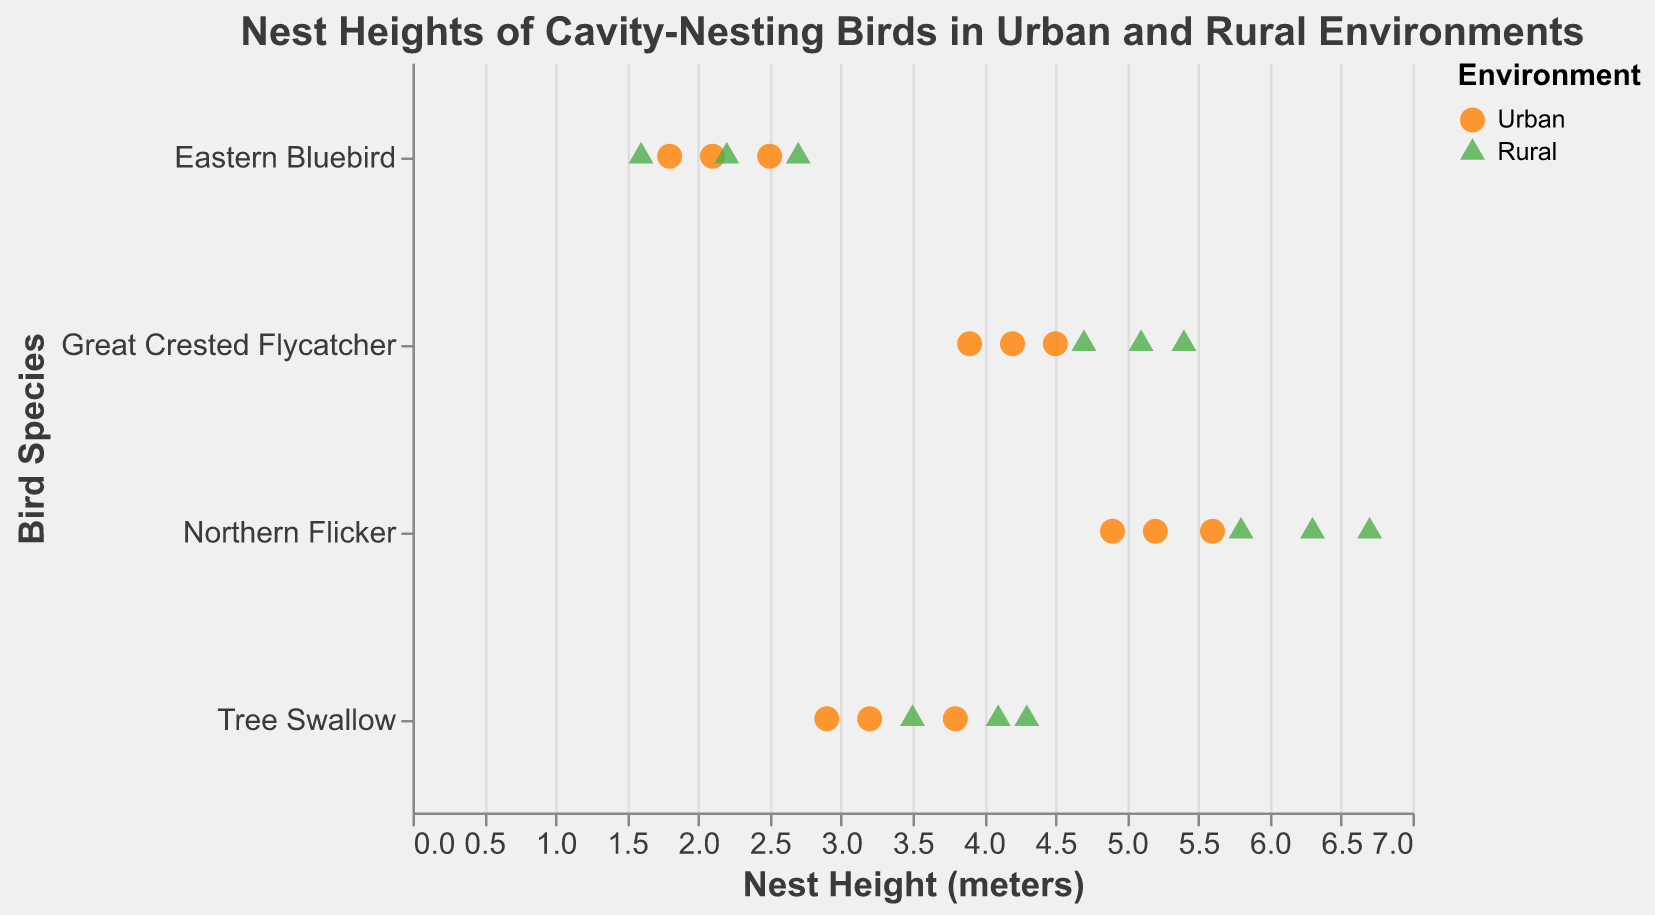How many data points are there for Eastern Bluebird nests in urban environments? Count the points corresponding to Eastern Bluebird in the Urban environment.
Answer: 3 Which species has the highest overall average nest height? Calculate the average nest height for each species by summing the nest heights and dividing by the number of points. Compare these averages. Northern Flicker: (5.6 + 4.9 + 5.2 + 6.3 + 5.8 + 6.7)/6 = 5.75, and this is the highest.
Answer: Northern Flicker Is there a species with nest heights consistently higher in rural environments compared to urban environments? Compare the nest heights for each species between rural and urban environments. Northern Flicker nest heights are higher in rural environments (6.3, 5.8, 6.7) than in urban environments (5.6, 4.9, 5.2).
Answer: Yes, Northern Flicker What is the range of nest heights for Tree Swallows in urban environments? Find the minimum and maximum nest heights for Tree Swallows in urban environments. The minimum is 2.9 and the maximum is 3.8. The range is 3.8 - 2.9.
Answer: 0.9 meters Does the Great Crested Flycatcher show a significant difference in nest height between urban and rural environments? Compare the nest heights for Great Crested Flycatcher in both environments. Urban: 4.5, 3.9, 4.2; Rural: 5.1, 4.7, 5.4. Calculate the average for urban (4.2) and rural (5.07) to see ~0.87 meter difference.
Answer: Yes, about 0.87 meters higher in rural How does the nest height of the lowest Eastern Bluebird in a rural environment compare to the highest in an urban environment? Find the minimum nest height for Eastern Bluebirds in rural (1.6) and the maximum in urban (2.5). Rural minimum is lower than Urban maximum.
Answer: Rural minimum is lower For which environment is the average nest height higher for Tree Swallows? Calculate the average nest height for Tree Swallows in urban and rural environments: Urban (3.2, 3.8, 2.9) = 3.3, Rural (4.1, 3.5, 4.3) = 3.97. Rural has a higher average.
Answer: Rural How much taller is the tallest nest height compared to the shortest for Northern Flickers? Identify the tallest (6.7) and shortest (4.9) nest heights for Northern Flickers. The difference is 6.7 - 4.9.
Answer: 1.8 meters What shape represents the urban environments in the strip plot? Identify the shape used in the strip plot legend for urban environments.
Answer: Circle 